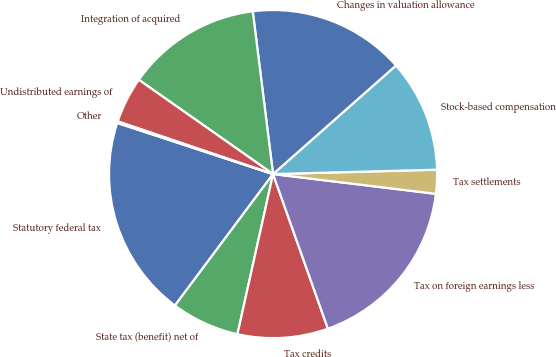Convert chart to OTSL. <chart><loc_0><loc_0><loc_500><loc_500><pie_chart><fcel>Statutory federal tax<fcel>State tax (benefit) net of<fcel>Tax credits<fcel>Tax on foreign earnings less<fcel>Tax settlements<fcel>Stock-based compensation<fcel>Changes in valuation allowance<fcel>Integration of acquired<fcel>Undistributed earnings of<fcel>Other<nl><fcel>19.84%<fcel>6.72%<fcel>8.91%<fcel>17.65%<fcel>2.35%<fcel>11.09%<fcel>15.46%<fcel>13.28%<fcel>4.54%<fcel>0.16%<nl></chart> 